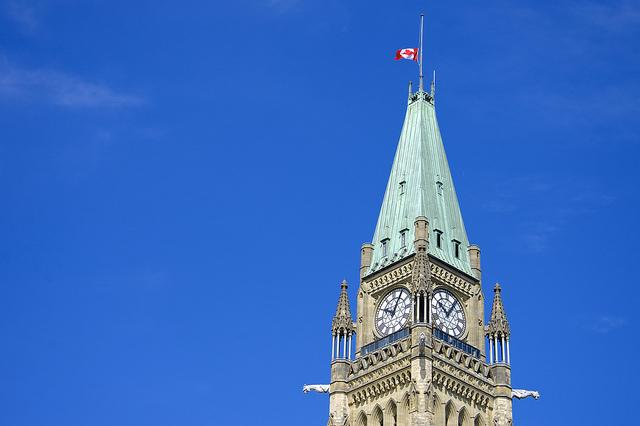How is the sky?
Give a very brief answer. Clear. What time does the clock say?
Quick response, please. 10:05. Where is this cathedral located?
Short answer required. Canada. What time does the clock show?
Short answer required. 10:05. What color is the very top of the building?
Answer briefly. Green. Is the flag half mast?
Answer briefly. Yes. 